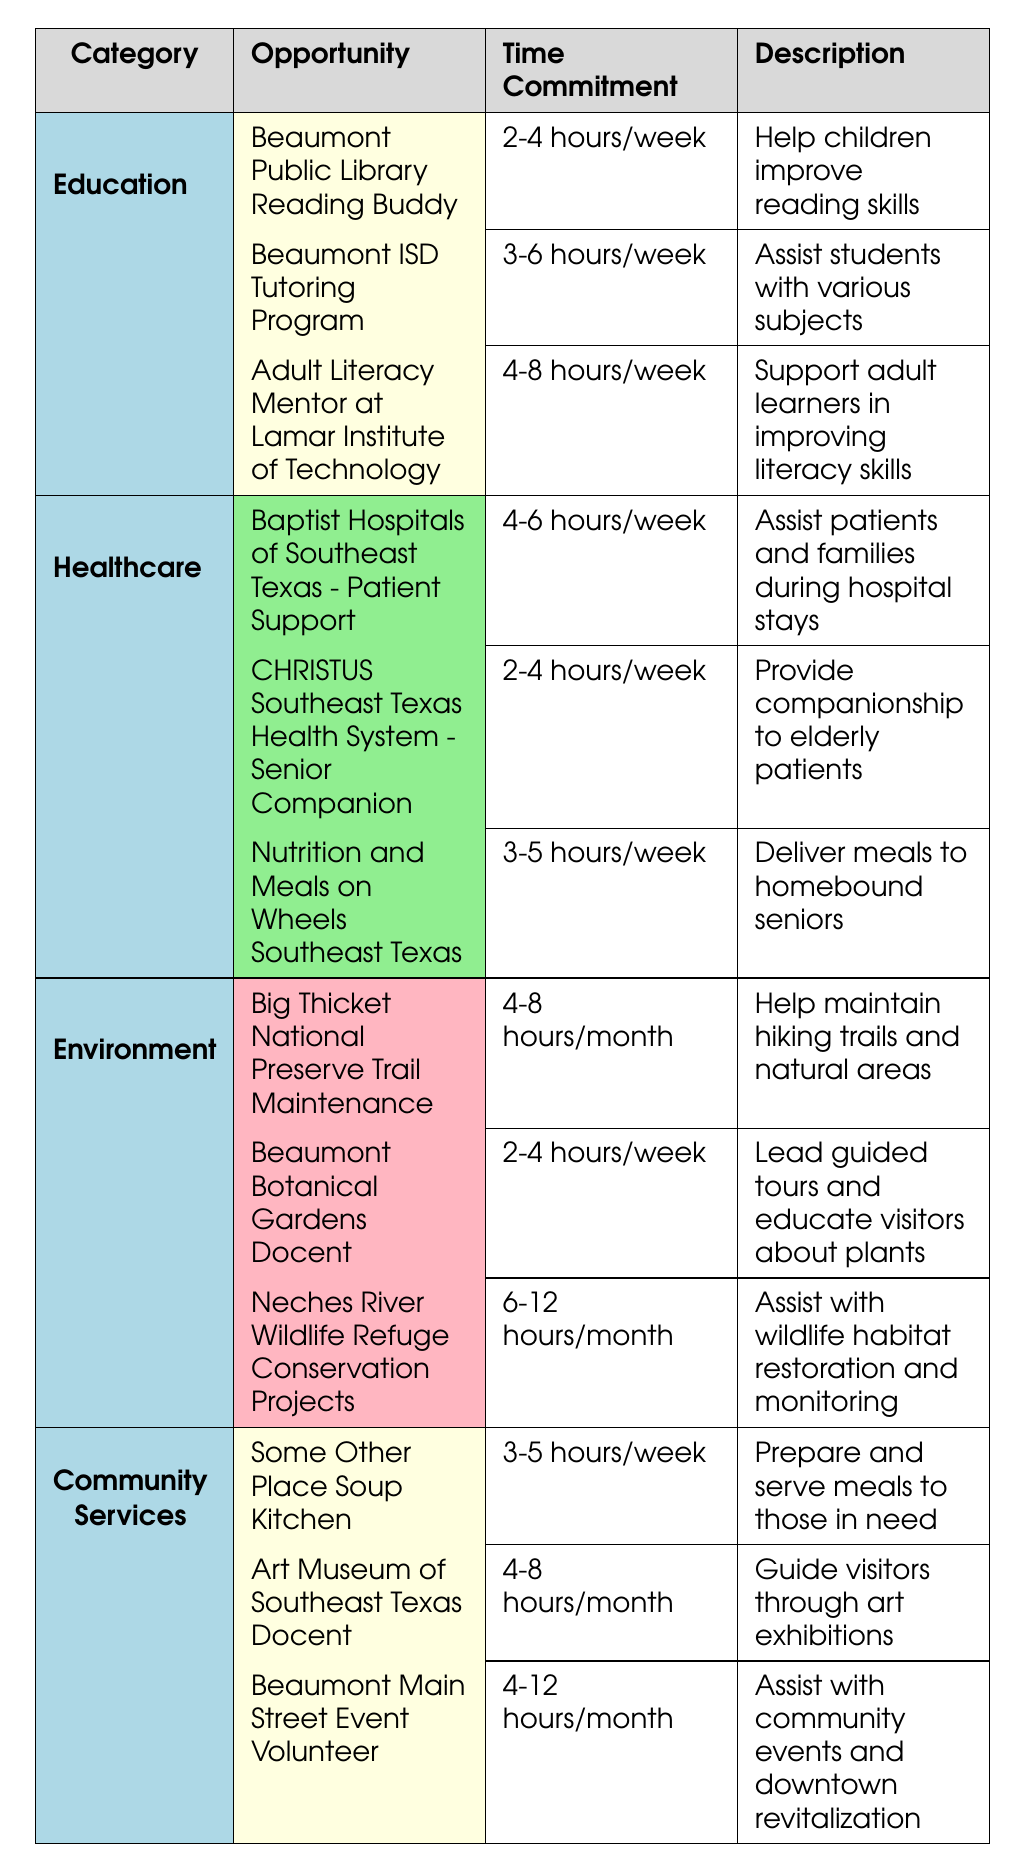What is the time commitment for the "Beaumont ISD Tutoring Program"? The time commitment for the "Beaumont ISD Tutoring Program" is listed in the table as "3-6 hours/week".
Answer: 3-6 hours/week Which category has a volunteer opportunity that requires 6-12 hours per month? In the table, the "Neches River Wildlife Refuge Conservation Projects" under the "Environment" category has a time commitment of "6-12 hours/month".
Answer: Environment Is there a healthcare opportunity that allows for companionship to elderly patients? The table shows that the "CHRISTUS Southeast Texas Health System - Senior Companion" falls under healthcare and provides companionship to elderly patients.
Answer: Yes How many opportunities are there in the Education category? The Education category has three opportunities listed: Beaumont Public Library Reading Buddy, Beaumont ISD Tutoring Program, and Adult Literacy Mentor at Lamar Institute of Technology.
Answer: 3 What is the time commitment range for opportunities in the Community Services category? The time commitments for the three opportunities in Community Services are: 3-5 hours/week, 4-8 hours/month, and 4-12 hours/month. The range includes both weekly and monthly commitments.
Answer: 3-5 hours/week and 4-12 hours/month Which category has the least time commitment for its opportunity? In the table, the "CHRISTUS Southeast Texas Health System - Senior Companion" in the Healthcare category has the least time commitment at "2-4 hours/week".
Answer: Healthcare How many categories have volunteer opportunities that require more than 4 hours per week? The Education category has one opportunity (Adult Literacy Mentor) requiring 4-8 hours/week, and the Healthcare category has one opportunity (Baptist Hospitals support) requiring 4-6 hours/week, making a total of two categories.
Answer: 2 Identify the total number of volunteer opportunities listed across all categories. There are a total of twelve opportunities listed across four categories: Education (3), Healthcare (3), Environment (3), and Community Services (3), summing to 3 + 3 + 3 + 3 = 12.
Answer: 12 Does the "Some Other Place Soup Kitchen" serve meals to those in need? The description for the "Some Other Place Soup Kitchen" in the table states that it prepares and serves meals to those in need.
Answer: Yes What is the average time commitment for the opportunities in the Environment category? The time commitments in the Environment category are 4-8 hours/month, 2-4 hours/week, and 6-12 hours/month. To average the time, we must convert all to a common unit, assuming 4 weeks/month as the baseline. Thus, it would be approximately 12 hours/month, 8-16 hours/month (range), and 6-12 hours/month giving a rough average of about 10 hours/month when averaged out.
Answer: 10 hours/month (average) 